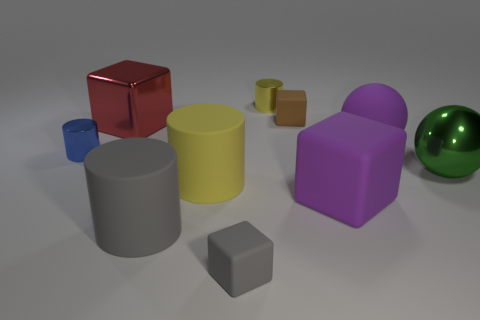Are the large block that is behind the green metal ball and the big purple thing that is in front of the tiny blue metallic cylinder made of the same material?
Give a very brief answer. No. What is the color of the other tiny object that is the same shape as the tiny blue shiny thing?
Give a very brief answer. Yellow. What material is the yellow cylinder that is in front of the tiny shiny thing that is on the right side of the big red metal thing?
Ensure brevity in your answer.  Rubber. Is the shape of the large metallic thing that is to the right of the purple rubber cube the same as the small rubber thing to the right of the yellow shiny thing?
Provide a succinct answer. No. There is a block that is both behind the large gray rubber object and in front of the yellow rubber thing; what size is it?
Your answer should be very brief. Large. How many other objects are there of the same color as the big rubber block?
Your answer should be very brief. 1. Are the big cylinder that is behind the large purple cube and the green sphere made of the same material?
Your answer should be very brief. No. Are there fewer green shiny spheres behind the brown matte block than shiny objects in front of the big red metallic thing?
Keep it short and to the point. Yes. How many big cubes are on the right side of the tiny matte cube in front of the metallic cylinder that is to the left of the big gray rubber cylinder?
Your answer should be compact. 1. There is a tiny gray matte object; how many metallic things are in front of it?
Your response must be concise. 0. 